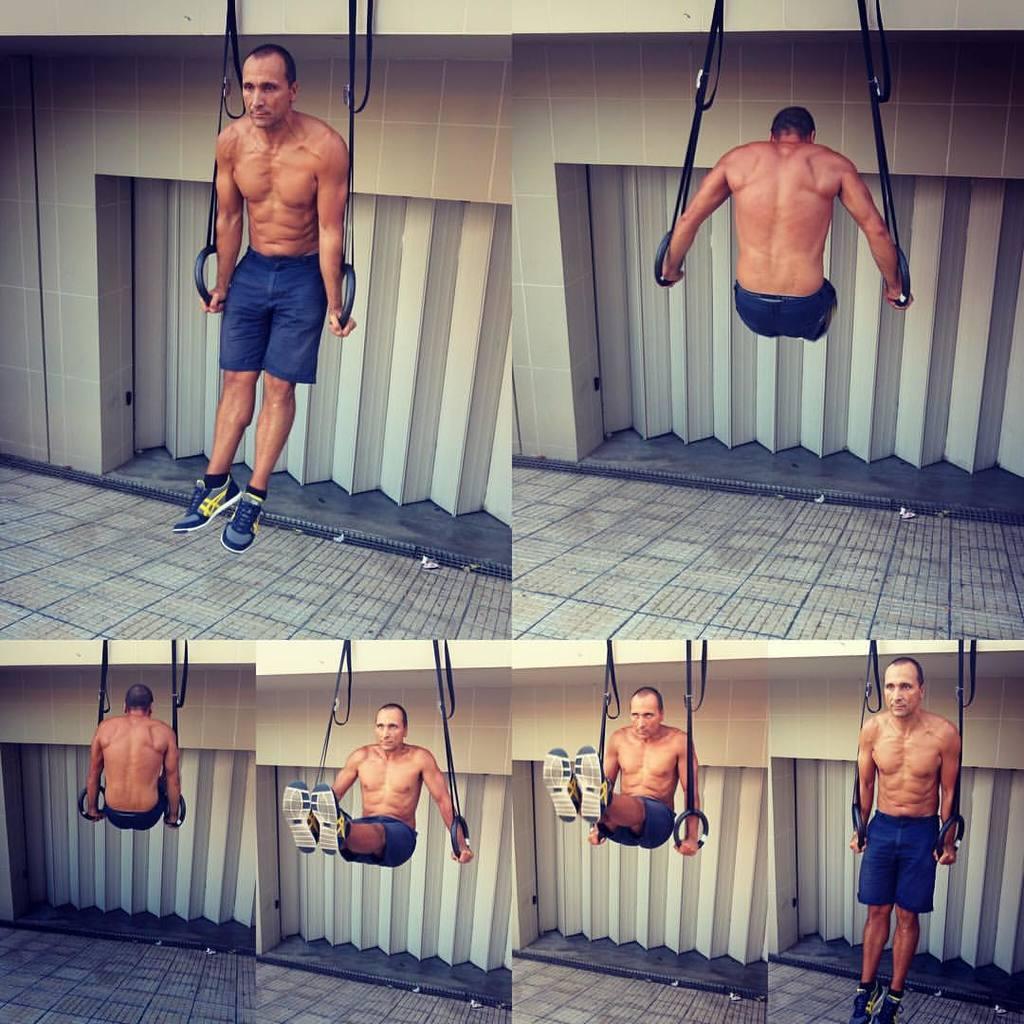How would you summarize this image in a sentence or two? This image is a collection of collages. In all of these images we can see a man doing pull up exercises. In the background we can see a wall. 